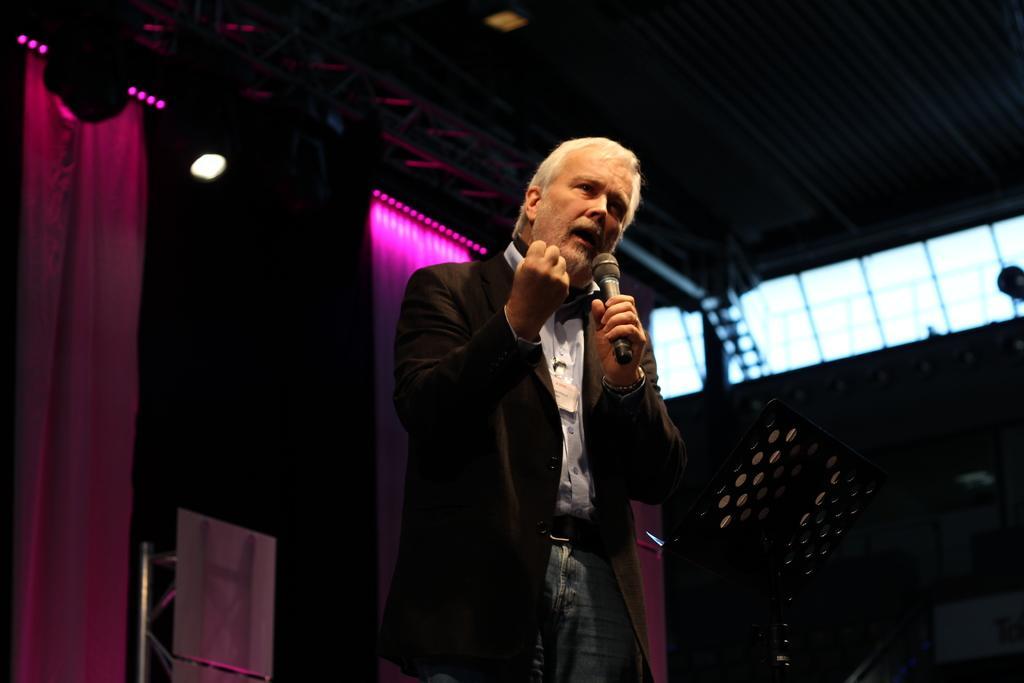In one or two sentences, can you explain what this image depicts? In this image I can see a man wearing suit, white shirt, holding mike in his hand and speaking something. At the background I can see a curtain, light and one stand. 